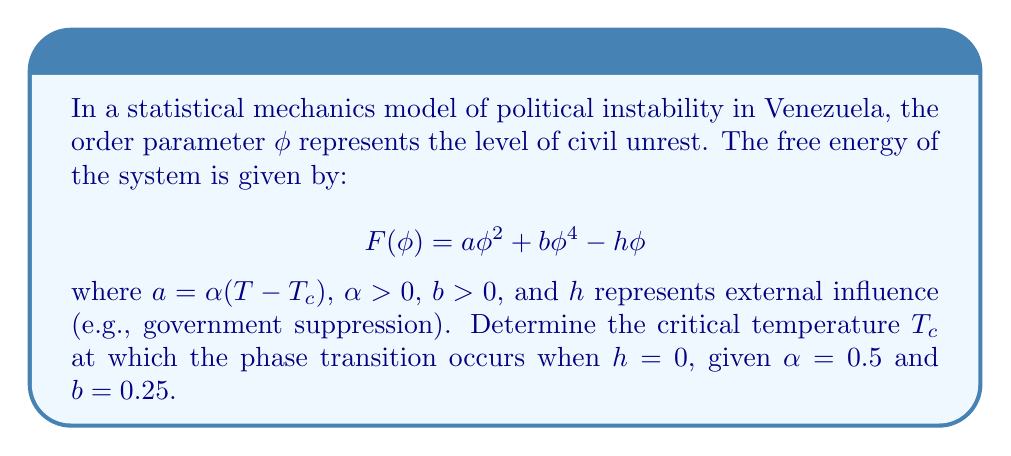Show me your answer to this math problem. 1. At the phase transition point, the system becomes unstable to small fluctuations. This occurs when the coefficient of the quadratic term in the free energy becomes zero.

2. The coefficient of the quadratic term is $a = \alpha(T - T_c)$.

3. At the phase transition, $a = 0$:
   
   $\alpha(T - T_c) = 0$

4. Solving for $T$:
   
   $T = T_c$

5. This means that the critical temperature $T_c$ is the temperature at which $a = 0$.

6. We are given that $\alpha = 0.5$. The value of $b$ is not needed for this calculation.

7. To find the exact value of $T_c$, we would need additional information about the relationship between temperature and the model parameters. However, we can conclude that the phase transition occurs at $T = T_c$, where $T_c$ is the temperature that makes $a = 0$.
Answer: $T = T_c$ 